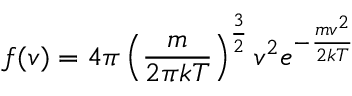<formula> <loc_0><loc_0><loc_500><loc_500>f ( v ) = 4 \pi \left ( { \frac { m } { 2 \pi k T } } \right ) ^ { \frac { 3 } { 2 } } v ^ { 2 } e ^ { - { \frac { m v ^ { 2 } } { 2 k T } } }</formula> 